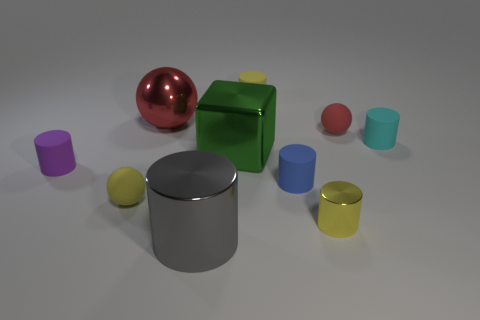Subtract all gray metallic cylinders. How many cylinders are left? 5 Subtract all yellow cylinders. How many cylinders are left? 4 Subtract 1 cylinders. How many cylinders are left? 5 Subtract all green cylinders. Subtract all green spheres. How many cylinders are left? 6 Subtract all blocks. How many objects are left? 9 Add 1 green matte things. How many green matte things exist? 1 Subtract 0 purple balls. How many objects are left? 10 Subtract all large purple metallic objects. Subtract all small purple rubber things. How many objects are left? 9 Add 2 small metallic cylinders. How many small metallic cylinders are left? 3 